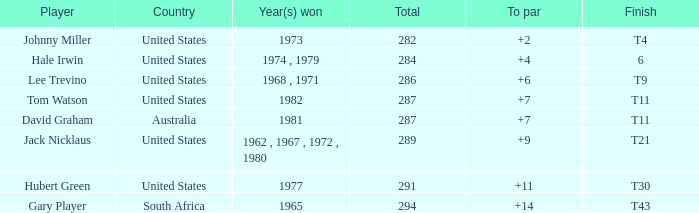WHAT IS THE TOTAL THAT HAS A WIN IN 1982? 287.0. 